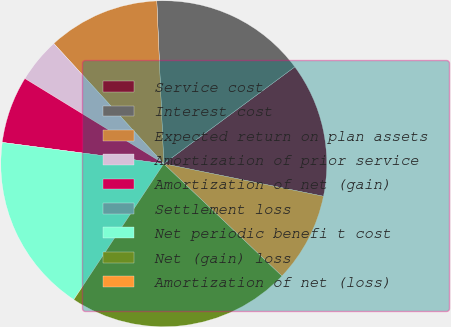Convert chart to OTSL. <chart><loc_0><loc_0><loc_500><loc_500><pie_chart><fcel>Service cost<fcel>Interest cost<fcel>Expected return on plan assets<fcel>Amortization of prior service<fcel>Amortization of net (gain)<fcel>Settlement loss<fcel>Net periodic benefi t cost<fcel>Net (gain) loss<fcel>Amortization of net (loss)<nl><fcel>13.33%<fcel>15.55%<fcel>11.11%<fcel>4.45%<fcel>6.67%<fcel>0.0%<fcel>17.78%<fcel>22.22%<fcel>8.89%<nl></chart> 